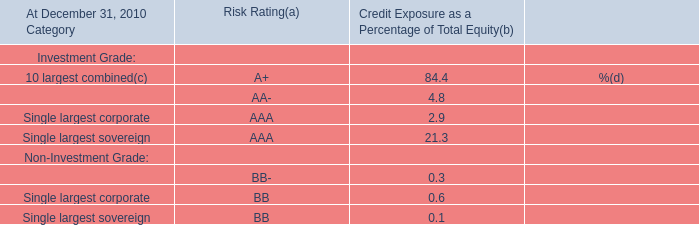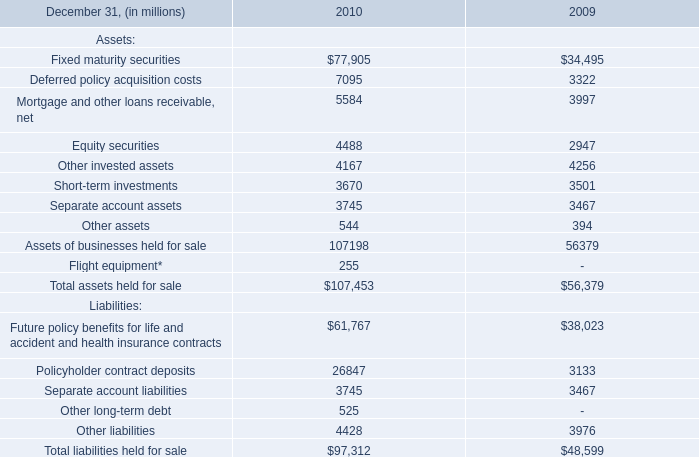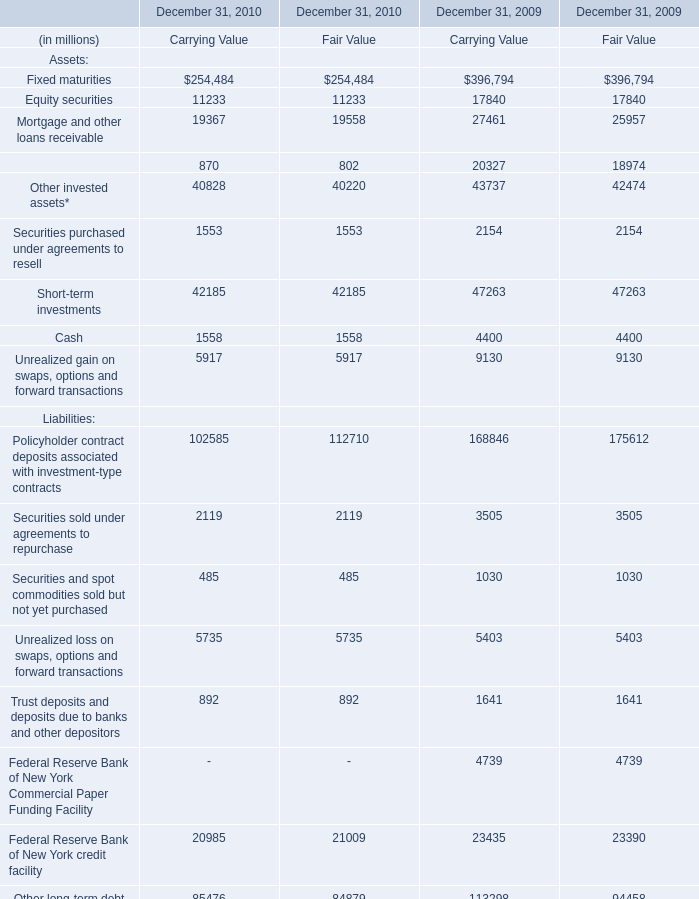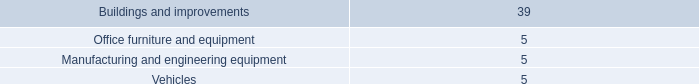What's the sum of Fixed maturity securities of 2010, and Equity securities of December 31, 2010 Carrying Value ? 
Computations: (77905.0 + 11233.0)
Answer: 89138.0. 